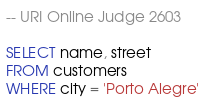Convert code to text. <code><loc_0><loc_0><loc_500><loc_500><_SQL_>-- URI Online Judge 2603

SELECT name, street
FROM customers
WHERE city = 'Porto Alegre'</code> 